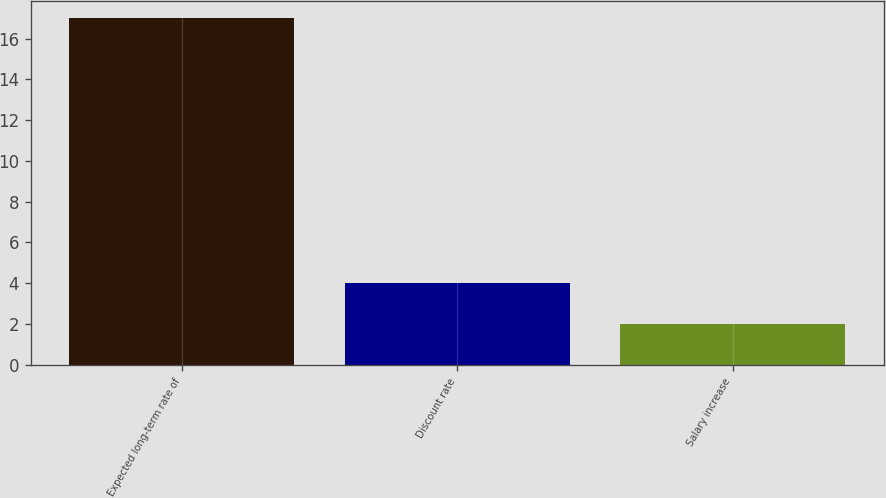<chart> <loc_0><loc_0><loc_500><loc_500><bar_chart><fcel>Expected long-term rate of<fcel>Discount rate<fcel>Salary increase<nl><fcel>17<fcel>4<fcel>2<nl></chart> 